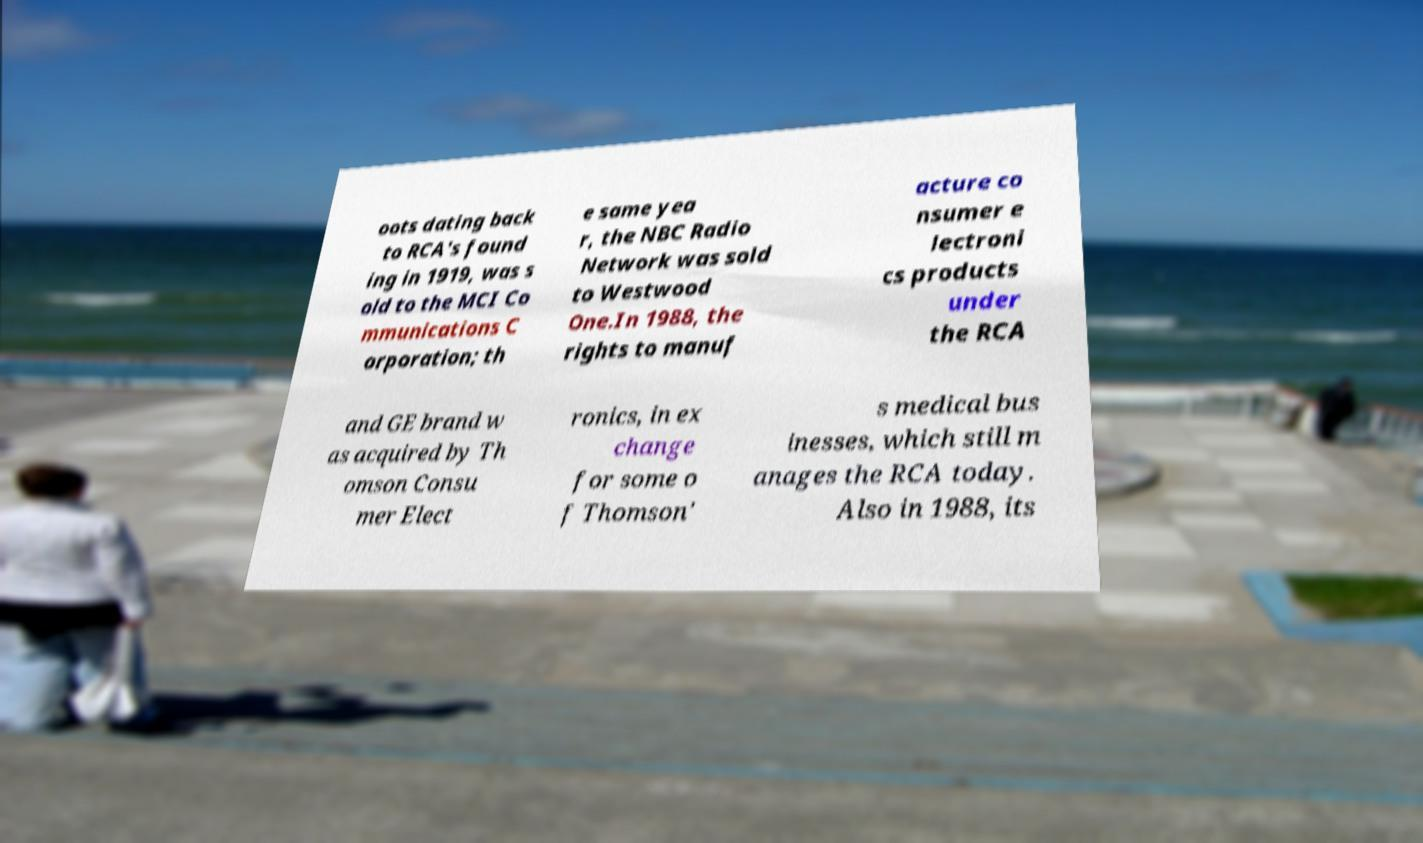Can you read and provide the text displayed in the image?This photo seems to have some interesting text. Can you extract and type it out for me? oots dating back to RCA's found ing in 1919, was s old to the MCI Co mmunications C orporation; th e same yea r, the NBC Radio Network was sold to Westwood One.In 1988, the rights to manuf acture co nsumer e lectroni cs products under the RCA and GE brand w as acquired by Th omson Consu mer Elect ronics, in ex change for some o f Thomson' s medical bus inesses, which still m anages the RCA today. Also in 1988, its 